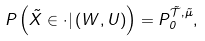<formula> <loc_0><loc_0><loc_500><loc_500>P \left ( \tilde { X } \in \cdot | \, ( W , U ) \right ) = { P } ^ { \tilde { \mathcal { T } } , \tilde { \mu } } _ { 0 } ,</formula> 